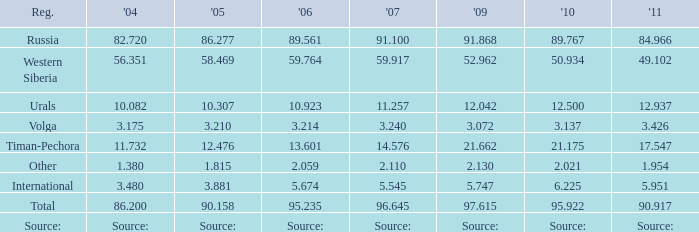What is the 2010 Lukoil oil prodroduction when in 2009 oil production 21.662 million tonnes? 21.175. 